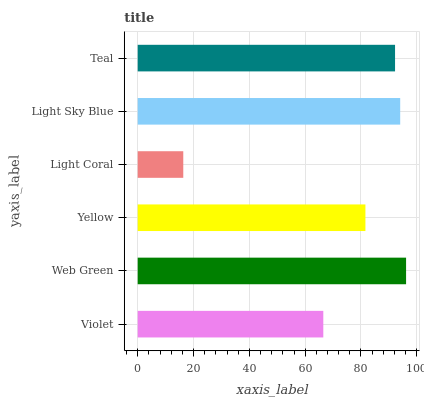Is Light Coral the minimum?
Answer yes or no. Yes. Is Web Green the maximum?
Answer yes or no. Yes. Is Yellow the minimum?
Answer yes or no. No. Is Yellow the maximum?
Answer yes or no. No. Is Web Green greater than Yellow?
Answer yes or no. Yes. Is Yellow less than Web Green?
Answer yes or no. Yes. Is Yellow greater than Web Green?
Answer yes or no. No. Is Web Green less than Yellow?
Answer yes or no. No. Is Teal the high median?
Answer yes or no. Yes. Is Yellow the low median?
Answer yes or no. Yes. Is Light Coral the high median?
Answer yes or no. No. Is Violet the low median?
Answer yes or no. No. 